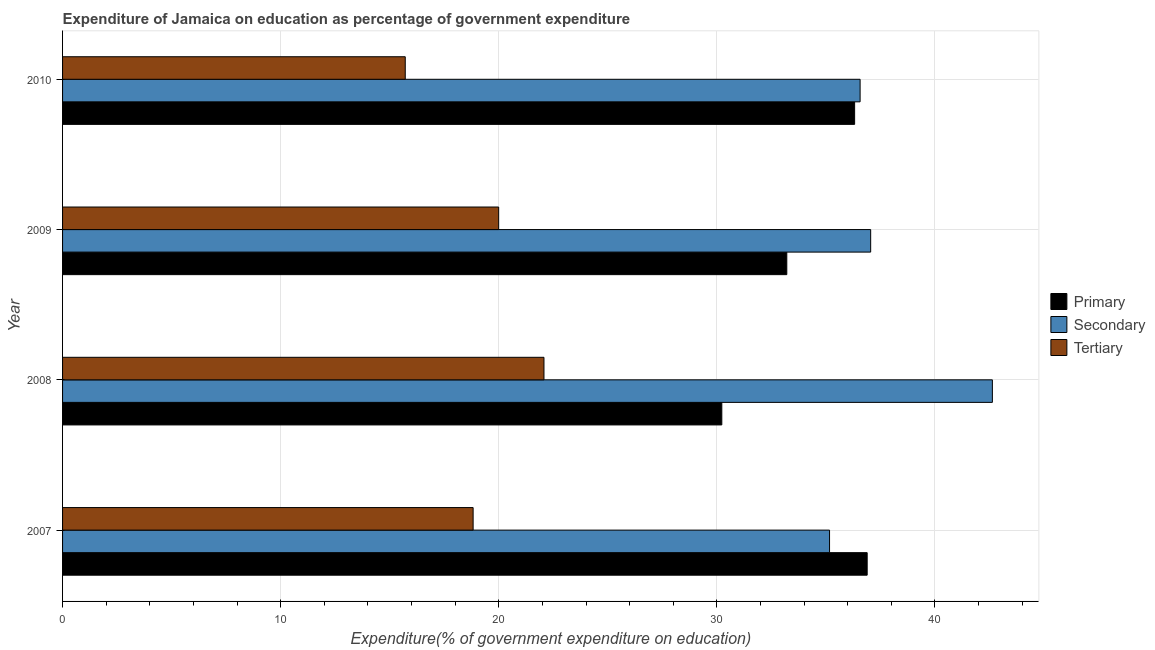How many different coloured bars are there?
Make the answer very short. 3. How many groups of bars are there?
Offer a very short reply. 4. Are the number of bars per tick equal to the number of legend labels?
Your response must be concise. Yes. How many bars are there on the 4th tick from the top?
Give a very brief answer. 3. What is the label of the 4th group of bars from the top?
Offer a terse response. 2007. What is the expenditure on tertiary education in 2009?
Provide a short and direct response. 20. Across all years, what is the maximum expenditure on tertiary education?
Make the answer very short. 22.07. Across all years, what is the minimum expenditure on tertiary education?
Offer a very short reply. 15.71. In which year was the expenditure on secondary education maximum?
Your response must be concise. 2008. In which year was the expenditure on secondary education minimum?
Your answer should be compact. 2007. What is the total expenditure on tertiary education in the graph?
Offer a terse response. 76.6. What is the difference between the expenditure on primary education in 2008 and that in 2010?
Offer a terse response. -6.09. What is the difference between the expenditure on tertiary education in 2008 and the expenditure on secondary education in 2010?
Make the answer very short. -14.49. What is the average expenditure on primary education per year?
Provide a short and direct response. 34.16. In the year 2008, what is the difference between the expenditure on secondary education and expenditure on tertiary education?
Keep it short and to the point. 20.56. In how many years, is the expenditure on tertiary education greater than 10 %?
Ensure brevity in your answer.  4. What is the ratio of the expenditure on primary education in 2007 to that in 2008?
Offer a very short reply. 1.22. What is the difference between the highest and the second highest expenditure on secondary education?
Provide a short and direct response. 5.58. What is the difference between the highest and the lowest expenditure on tertiary education?
Make the answer very short. 6.36. Is the sum of the expenditure on secondary education in 2008 and 2009 greater than the maximum expenditure on primary education across all years?
Ensure brevity in your answer.  Yes. What does the 2nd bar from the top in 2007 represents?
Keep it short and to the point. Secondary. What does the 2nd bar from the bottom in 2008 represents?
Provide a succinct answer. Secondary. Is it the case that in every year, the sum of the expenditure on primary education and expenditure on secondary education is greater than the expenditure on tertiary education?
Your response must be concise. Yes. Are all the bars in the graph horizontal?
Your response must be concise. Yes. What is the difference between two consecutive major ticks on the X-axis?
Make the answer very short. 10. Are the values on the major ticks of X-axis written in scientific E-notation?
Your answer should be very brief. No. Where does the legend appear in the graph?
Provide a succinct answer. Center right. How many legend labels are there?
Ensure brevity in your answer.  3. What is the title of the graph?
Provide a succinct answer. Expenditure of Jamaica on education as percentage of government expenditure. Does "Ages 0-14" appear as one of the legend labels in the graph?
Offer a very short reply. No. What is the label or title of the X-axis?
Ensure brevity in your answer.  Expenditure(% of government expenditure on education). What is the Expenditure(% of government expenditure on education) of Primary in 2007?
Ensure brevity in your answer.  36.89. What is the Expenditure(% of government expenditure on education) in Secondary in 2007?
Give a very brief answer. 35.17. What is the Expenditure(% of government expenditure on education) of Tertiary in 2007?
Give a very brief answer. 18.82. What is the Expenditure(% of government expenditure on education) in Primary in 2008?
Ensure brevity in your answer.  30.23. What is the Expenditure(% of government expenditure on education) in Secondary in 2008?
Provide a short and direct response. 42.63. What is the Expenditure(% of government expenditure on education) in Tertiary in 2008?
Your answer should be very brief. 22.07. What is the Expenditure(% of government expenditure on education) of Primary in 2009?
Offer a very short reply. 33.21. What is the Expenditure(% of government expenditure on education) in Secondary in 2009?
Provide a short and direct response. 37.05. What is the Expenditure(% of government expenditure on education) of Tertiary in 2009?
Provide a short and direct response. 20. What is the Expenditure(% of government expenditure on education) of Primary in 2010?
Your answer should be compact. 36.32. What is the Expenditure(% of government expenditure on education) in Secondary in 2010?
Offer a very short reply. 36.57. What is the Expenditure(% of government expenditure on education) in Tertiary in 2010?
Ensure brevity in your answer.  15.71. Across all years, what is the maximum Expenditure(% of government expenditure on education) of Primary?
Keep it short and to the point. 36.89. Across all years, what is the maximum Expenditure(% of government expenditure on education) of Secondary?
Ensure brevity in your answer.  42.63. Across all years, what is the maximum Expenditure(% of government expenditure on education) of Tertiary?
Your answer should be compact. 22.07. Across all years, what is the minimum Expenditure(% of government expenditure on education) in Primary?
Offer a terse response. 30.23. Across all years, what is the minimum Expenditure(% of government expenditure on education) of Secondary?
Provide a succinct answer. 35.17. Across all years, what is the minimum Expenditure(% of government expenditure on education) of Tertiary?
Provide a succinct answer. 15.71. What is the total Expenditure(% of government expenditure on education) in Primary in the graph?
Provide a short and direct response. 136.64. What is the total Expenditure(% of government expenditure on education) of Secondary in the graph?
Provide a short and direct response. 151.42. What is the total Expenditure(% of government expenditure on education) of Tertiary in the graph?
Give a very brief answer. 76.6. What is the difference between the Expenditure(% of government expenditure on education) in Primary in 2007 and that in 2008?
Offer a terse response. 6.67. What is the difference between the Expenditure(% of government expenditure on education) in Secondary in 2007 and that in 2008?
Offer a terse response. -7.47. What is the difference between the Expenditure(% of government expenditure on education) of Tertiary in 2007 and that in 2008?
Your answer should be compact. -3.25. What is the difference between the Expenditure(% of government expenditure on education) of Primary in 2007 and that in 2009?
Your response must be concise. 3.69. What is the difference between the Expenditure(% of government expenditure on education) of Secondary in 2007 and that in 2009?
Your response must be concise. -1.89. What is the difference between the Expenditure(% of government expenditure on education) in Tertiary in 2007 and that in 2009?
Ensure brevity in your answer.  -1.17. What is the difference between the Expenditure(% of government expenditure on education) of Primary in 2007 and that in 2010?
Keep it short and to the point. 0.58. What is the difference between the Expenditure(% of government expenditure on education) in Secondary in 2007 and that in 2010?
Keep it short and to the point. -1.4. What is the difference between the Expenditure(% of government expenditure on education) in Tertiary in 2007 and that in 2010?
Provide a short and direct response. 3.11. What is the difference between the Expenditure(% of government expenditure on education) in Primary in 2008 and that in 2009?
Your response must be concise. -2.98. What is the difference between the Expenditure(% of government expenditure on education) in Secondary in 2008 and that in 2009?
Give a very brief answer. 5.58. What is the difference between the Expenditure(% of government expenditure on education) in Tertiary in 2008 and that in 2009?
Your answer should be very brief. 2.08. What is the difference between the Expenditure(% of government expenditure on education) in Primary in 2008 and that in 2010?
Offer a terse response. -6.09. What is the difference between the Expenditure(% of government expenditure on education) in Secondary in 2008 and that in 2010?
Your answer should be compact. 6.06. What is the difference between the Expenditure(% of government expenditure on education) in Tertiary in 2008 and that in 2010?
Provide a short and direct response. 6.36. What is the difference between the Expenditure(% of government expenditure on education) in Primary in 2009 and that in 2010?
Your answer should be very brief. -3.11. What is the difference between the Expenditure(% of government expenditure on education) in Secondary in 2009 and that in 2010?
Keep it short and to the point. 0.48. What is the difference between the Expenditure(% of government expenditure on education) of Tertiary in 2009 and that in 2010?
Provide a succinct answer. 4.28. What is the difference between the Expenditure(% of government expenditure on education) in Primary in 2007 and the Expenditure(% of government expenditure on education) in Secondary in 2008?
Offer a terse response. -5.74. What is the difference between the Expenditure(% of government expenditure on education) in Primary in 2007 and the Expenditure(% of government expenditure on education) in Tertiary in 2008?
Provide a short and direct response. 14.82. What is the difference between the Expenditure(% of government expenditure on education) in Secondary in 2007 and the Expenditure(% of government expenditure on education) in Tertiary in 2008?
Offer a very short reply. 13.09. What is the difference between the Expenditure(% of government expenditure on education) of Primary in 2007 and the Expenditure(% of government expenditure on education) of Secondary in 2009?
Make the answer very short. -0.16. What is the difference between the Expenditure(% of government expenditure on education) of Primary in 2007 and the Expenditure(% of government expenditure on education) of Tertiary in 2009?
Ensure brevity in your answer.  16.9. What is the difference between the Expenditure(% of government expenditure on education) in Secondary in 2007 and the Expenditure(% of government expenditure on education) in Tertiary in 2009?
Your answer should be very brief. 15.17. What is the difference between the Expenditure(% of government expenditure on education) of Primary in 2007 and the Expenditure(% of government expenditure on education) of Secondary in 2010?
Offer a terse response. 0.32. What is the difference between the Expenditure(% of government expenditure on education) in Primary in 2007 and the Expenditure(% of government expenditure on education) in Tertiary in 2010?
Offer a terse response. 21.18. What is the difference between the Expenditure(% of government expenditure on education) of Secondary in 2007 and the Expenditure(% of government expenditure on education) of Tertiary in 2010?
Provide a short and direct response. 19.45. What is the difference between the Expenditure(% of government expenditure on education) of Primary in 2008 and the Expenditure(% of government expenditure on education) of Secondary in 2009?
Give a very brief answer. -6.83. What is the difference between the Expenditure(% of government expenditure on education) of Primary in 2008 and the Expenditure(% of government expenditure on education) of Tertiary in 2009?
Ensure brevity in your answer.  10.23. What is the difference between the Expenditure(% of government expenditure on education) in Secondary in 2008 and the Expenditure(% of government expenditure on education) in Tertiary in 2009?
Your answer should be compact. 22.64. What is the difference between the Expenditure(% of government expenditure on education) in Primary in 2008 and the Expenditure(% of government expenditure on education) in Secondary in 2010?
Your answer should be very brief. -6.34. What is the difference between the Expenditure(% of government expenditure on education) of Primary in 2008 and the Expenditure(% of government expenditure on education) of Tertiary in 2010?
Provide a short and direct response. 14.51. What is the difference between the Expenditure(% of government expenditure on education) in Secondary in 2008 and the Expenditure(% of government expenditure on education) in Tertiary in 2010?
Your response must be concise. 26.92. What is the difference between the Expenditure(% of government expenditure on education) in Primary in 2009 and the Expenditure(% of government expenditure on education) in Secondary in 2010?
Offer a very short reply. -3.36. What is the difference between the Expenditure(% of government expenditure on education) of Primary in 2009 and the Expenditure(% of government expenditure on education) of Tertiary in 2010?
Offer a very short reply. 17.49. What is the difference between the Expenditure(% of government expenditure on education) of Secondary in 2009 and the Expenditure(% of government expenditure on education) of Tertiary in 2010?
Keep it short and to the point. 21.34. What is the average Expenditure(% of government expenditure on education) in Primary per year?
Make the answer very short. 34.16. What is the average Expenditure(% of government expenditure on education) in Secondary per year?
Offer a terse response. 37.85. What is the average Expenditure(% of government expenditure on education) of Tertiary per year?
Your response must be concise. 19.15. In the year 2007, what is the difference between the Expenditure(% of government expenditure on education) of Primary and Expenditure(% of government expenditure on education) of Secondary?
Your response must be concise. 1.73. In the year 2007, what is the difference between the Expenditure(% of government expenditure on education) in Primary and Expenditure(% of government expenditure on education) in Tertiary?
Ensure brevity in your answer.  18.07. In the year 2007, what is the difference between the Expenditure(% of government expenditure on education) of Secondary and Expenditure(% of government expenditure on education) of Tertiary?
Your answer should be compact. 16.34. In the year 2008, what is the difference between the Expenditure(% of government expenditure on education) of Primary and Expenditure(% of government expenditure on education) of Secondary?
Provide a short and direct response. -12.41. In the year 2008, what is the difference between the Expenditure(% of government expenditure on education) in Primary and Expenditure(% of government expenditure on education) in Tertiary?
Provide a short and direct response. 8.15. In the year 2008, what is the difference between the Expenditure(% of government expenditure on education) of Secondary and Expenditure(% of government expenditure on education) of Tertiary?
Provide a succinct answer. 20.56. In the year 2009, what is the difference between the Expenditure(% of government expenditure on education) of Primary and Expenditure(% of government expenditure on education) of Secondary?
Your answer should be compact. -3.85. In the year 2009, what is the difference between the Expenditure(% of government expenditure on education) of Primary and Expenditure(% of government expenditure on education) of Tertiary?
Your answer should be very brief. 13.21. In the year 2009, what is the difference between the Expenditure(% of government expenditure on education) in Secondary and Expenditure(% of government expenditure on education) in Tertiary?
Make the answer very short. 17.06. In the year 2010, what is the difference between the Expenditure(% of government expenditure on education) in Primary and Expenditure(% of government expenditure on education) in Secondary?
Keep it short and to the point. -0.25. In the year 2010, what is the difference between the Expenditure(% of government expenditure on education) in Primary and Expenditure(% of government expenditure on education) in Tertiary?
Give a very brief answer. 20.6. In the year 2010, what is the difference between the Expenditure(% of government expenditure on education) in Secondary and Expenditure(% of government expenditure on education) in Tertiary?
Your answer should be very brief. 20.86. What is the ratio of the Expenditure(% of government expenditure on education) of Primary in 2007 to that in 2008?
Your response must be concise. 1.22. What is the ratio of the Expenditure(% of government expenditure on education) of Secondary in 2007 to that in 2008?
Provide a succinct answer. 0.82. What is the ratio of the Expenditure(% of government expenditure on education) in Tertiary in 2007 to that in 2008?
Keep it short and to the point. 0.85. What is the ratio of the Expenditure(% of government expenditure on education) of Primary in 2007 to that in 2009?
Provide a succinct answer. 1.11. What is the ratio of the Expenditure(% of government expenditure on education) of Secondary in 2007 to that in 2009?
Your answer should be compact. 0.95. What is the ratio of the Expenditure(% of government expenditure on education) in Tertiary in 2007 to that in 2009?
Keep it short and to the point. 0.94. What is the ratio of the Expenditure(% of government expenditure on education) in Primary in 2007 to that in 2010?
Ensure brevity in your answer.  1.02. What is the ratio of the Expenditure(% of government expenditure on education) in Secondary in 2007 to that in 2010?
Your response must be concise. 0.96. What is the ratio of the Expenditure(% of government expenditure on education) of Tertiary in 2007 to that in 2010?
Provide a short and direct response. 1.2. What is the ratio of the Expenditure(% of government expenditure on education) of Primary in 2008 to that in 2009?
Your answer should be very brief. 0.91. What is the ratio of the Expenditure(% of government expenditure on education) of Secondary in 2008 to that in 2009?
Your answer should be compact. 1.15. What is the ratio of the Expenditure(% of government expenditure on education) of Tertiary in 2008 to that in 2009?
Provide a succinct answer. 1.1. What is the ratio of the Expenditure(% of government expenditure on education) in Primary in 2008 to that in 2010?
Give a very brief answer. 0.83. What is the ratio of the Expenditure(% of government expenditure on education) of Secondary in 2008 to that in 2010?
Your response must be concise. 1.17. What is the ratio of the Expenditure(% of government expenditure on education) in Tertiary in 2008 to that in 2010?
Offer a very short reply. 1.4. What is the ratio of the Expenditure(% of government expenditure on education) in Primary in 2009 to that in 2010?
Keep it short and to the point. 0.91. What is the ratio of the Expenditure(% of government expenditure on education) in Secondary in 2009 to that in 2010?
Provide a succinct answer. 1.01. What is the ratio of the Expenditure(% of government expenditure on education) in Tertiary in 2009 to that in 2010?
Your response must be concise. 1.27. What is the difference between the highest and the second highest Expenditure(% of government expenditure on education) of Primary?
Your answer should be compact. 0.58. What is the difference between the highest and the second highest Expenditure(% of government expenditure on education) of Secondary?
Offer a terse response. 5.58. What is the difference between the highest and the second highest Expenditure(% of government expenditure on education) in Tertiary?
Provide a short and direct response. 2.08. What is the difference between the highest and the lowest Expenditure(% of government expenditure on education) in Primary?
Provide a succinct answer. 6.67. What is the difference between the highest and the lowest Expenditure(% of government expenditure on education) in Secondary?
Provide a succinct answer. 7.47. What is the difference between the highest and the lowest Expenditure(% of government expenditure on education) in Tertiary?
Offer a terse response. 6.36. 